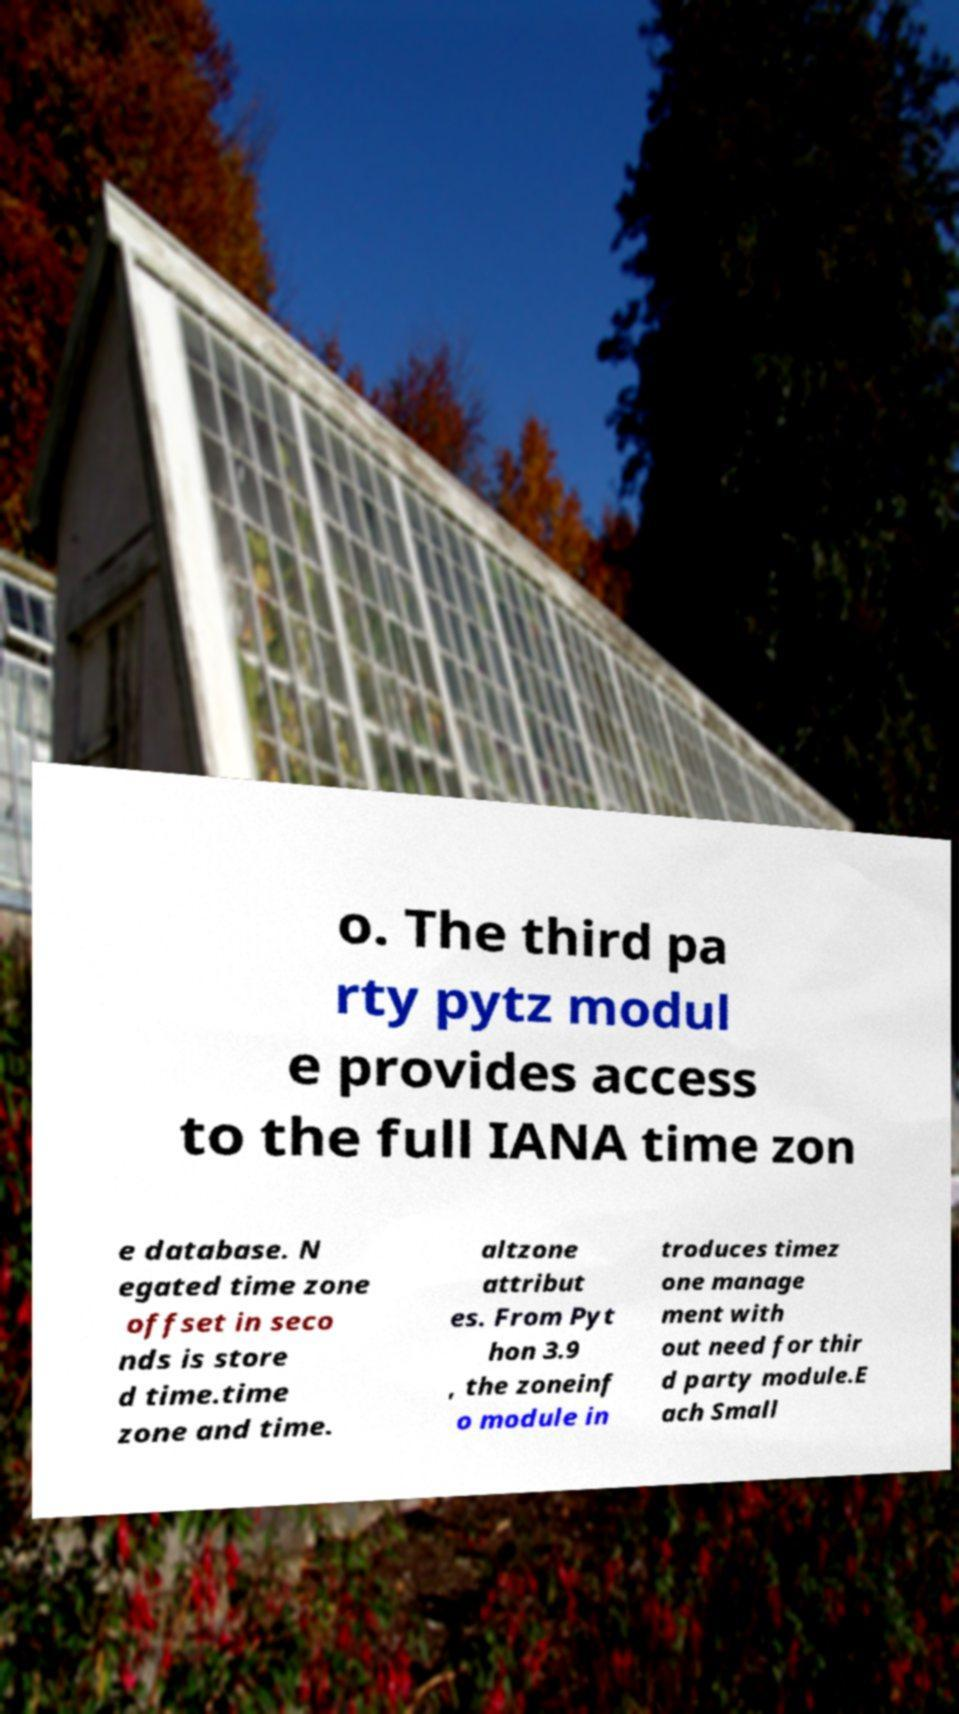There's text embedded in this image that I need extracted. Can you transcribe it verbatim? o. The third pa rty pytz modul e provides access to the full IANA time zon e database. N egated time zone offset in seco nds is store d time.time zone and time. altzone attribut es. From Pyt hon 3.9 , the zoneinf o module in troduces timez one manage ment with out need for thir d party module.E ach Small 